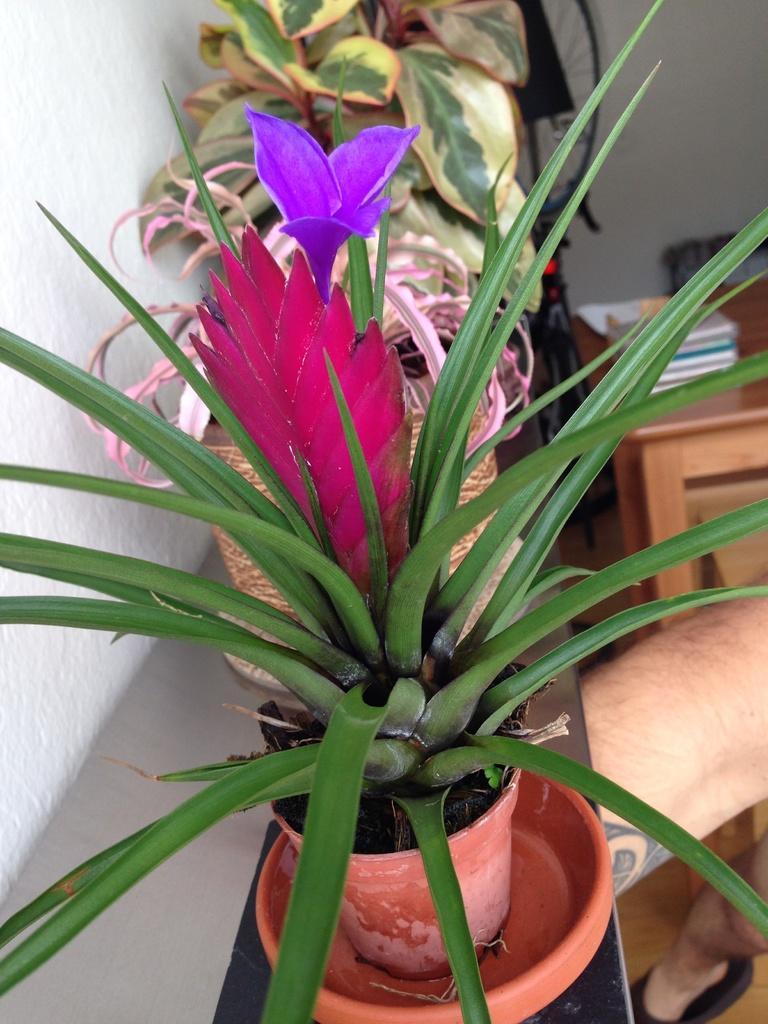Can you describe this image briefly? In this image there are flower pots on the desk, books on the table, a wheel on the stand, a person and the wall. 